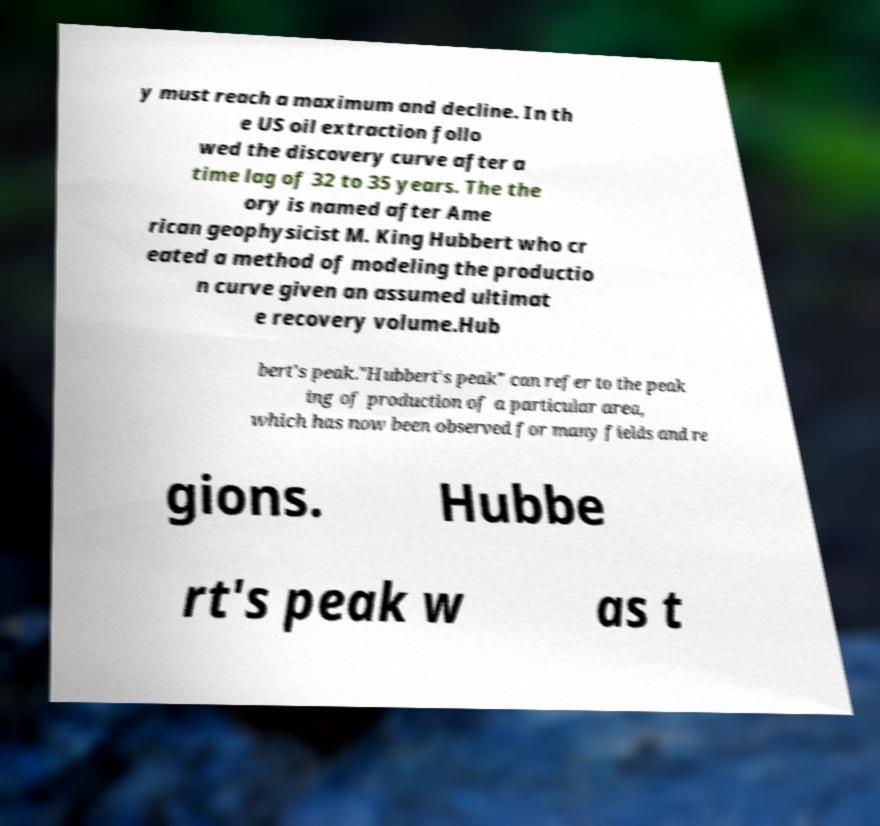Could you extract and type out the text from this image? y must reach a maximum and decline. In th e US oil extraction follo wed the discovery curve after a time lag of 32 to 35 years. The the ory is named after Ame rican geophysicist M. King Hubbert who cr eated a method of modeling the productio n curve given an assumed ultimat e recovery volume.Hub bert's peak."Hubbert's peak" can refer to the peak ing of production of a particular area, which has now been observed for many fields and re gions. Hubbe rt's peak w as t 